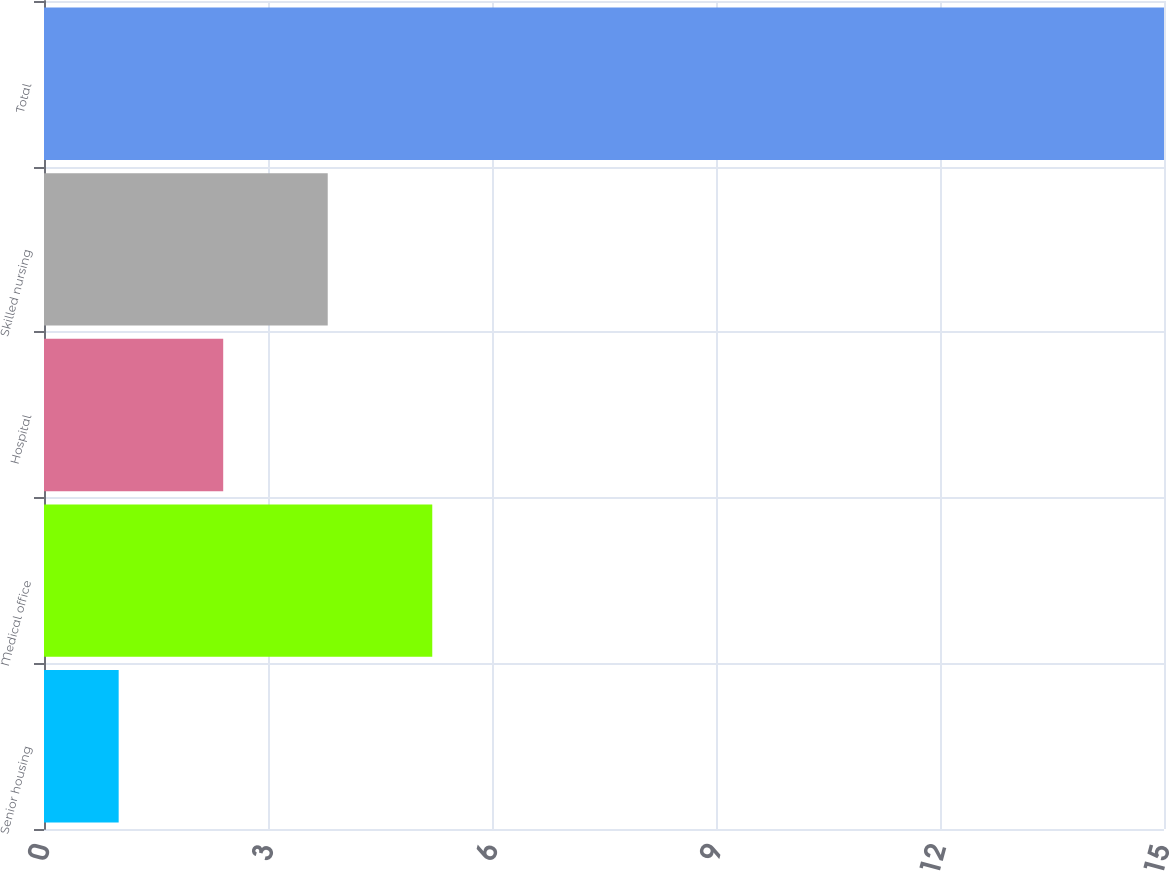Convert chart to OTSL. <chart><loc_0><loc_0><loc_500><loc_500><bar_chart><fcel>Senior housing<fcel>Medical office<fcel>Hospital<fcel>Skilled nursing<fcel>Total<nl><fcel>1<fcel>5.2<fcel>2.4<fcel>3.8<fcel>15<nl></chart> 